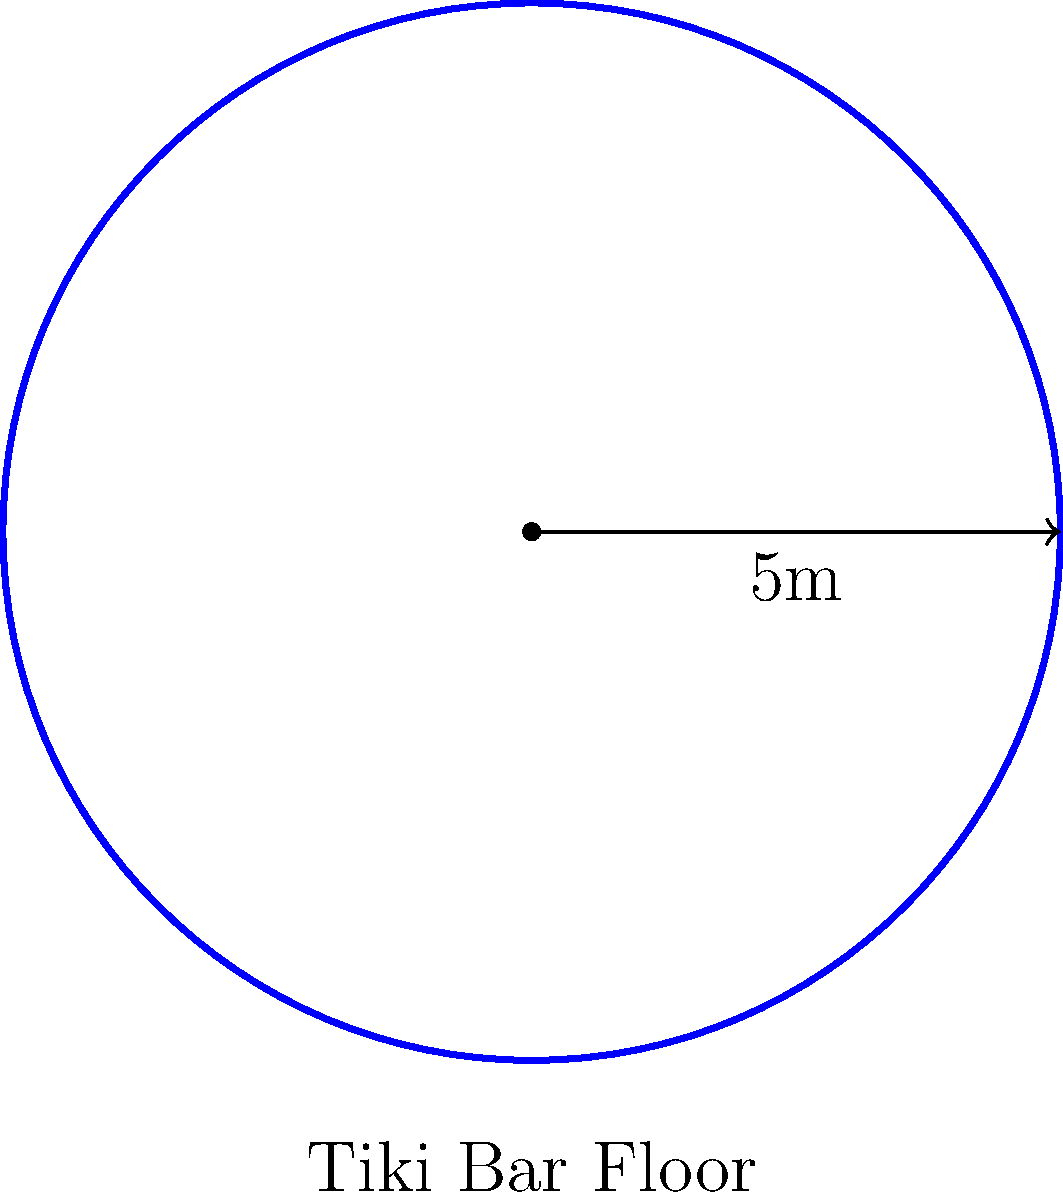You're planning to install a new circular dance floor in your tiki bar for an upcoming charity event. If the radius of the floor is 5 meters, what is the total area of the dance floor in square meters? Round your answer to two decimal places. To find the area of a circular dance floor, we need to use the formula for the area of a circle:

$$A = \pi r^2$$

Where:
$A$ = Area of the circle
$\pi$ = Pi (approximately 3.14159)
$r$ = Radius of the circle

Given:
Radius ($r$) = 5 meters

Let's calculate:

1) Substitute the values into the formula:
   $$A = \pi \times 5^2$$

2) Calculate the square of the radius:
   $$A = \pi \times 25$$

3) Multiply by $\pi$:
   $$A = 3.14159 \times 25 = 78.53975$$

4) Round to two decimal places:
   $$A \approx 78.54 \text{ m}^2$$

Therefore, the area of the circular tiki bar dance floor is approximately 78.54 square meters.
Answer: 78.54 m² 